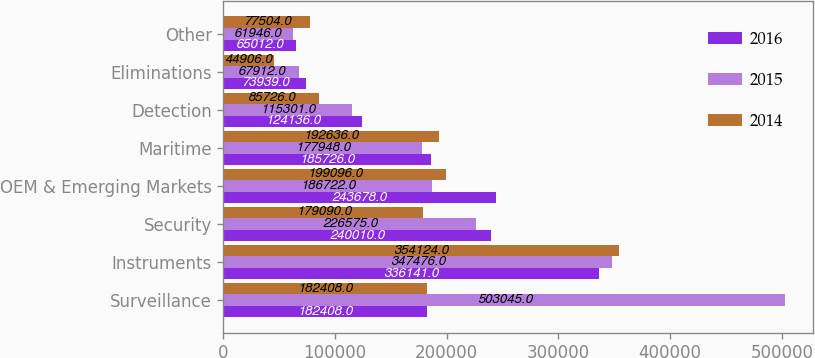Convert chart to OTSL. <chart><loc_0><loc_0><loc_500><loc_500><stacked_bar_chart><ecel><fcel>Surveillance<fcel>Instruments<fcel>Security<fcel>OEM & Emerging Markets<fcel>Maritime<fcel>Detection<fcel>Eliminations<fcel>Other<nl><fcel>2016<fcel>182408<fcel>336141<fcel>240010<fcel>243678<fcel>185726<fcel>124136<fcel>73939<fcel>65012<nl><fcel>2015<fcel>503045<fcel>347476<fcel>226575<fcel>186722<fcel>177948<fcel>115301<fcel>67912<fcel>61946<nl><fcel>2014<fcel>182408<fcel>354124<fcel>179090<fcel>199096<fcel>192636<fcel>85726<fcel>44906<fcel>77504<nl></chart> 